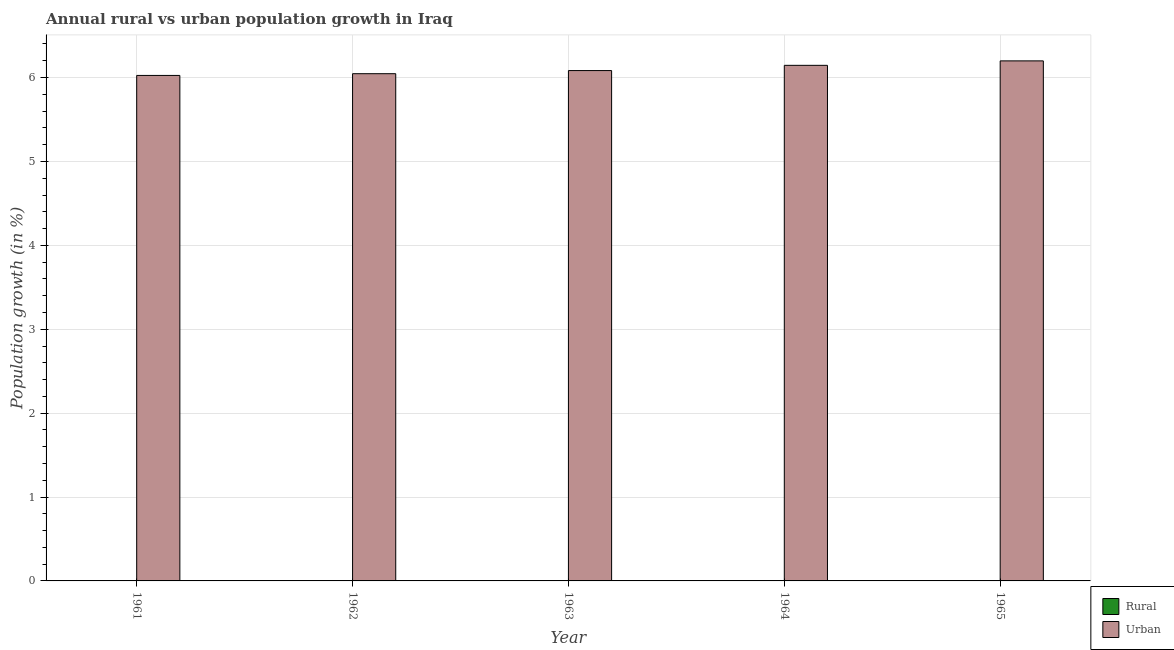Are the number of bars per tick equal to the number of legend labels?
Provide a succinct answer. No. What is the label of the 1st group of bars from the left?
Offer a terse response. 1961. In how many cases, is the number of bars for a given year not equal to the number of legend labels?
Ensure brevity in your answer.  5. Across all years, what is the maximum urban population growth?
Offer a terse response. 6.2. In which year was the urban population growth maximum?
Make the answer very short. 1965. What is the total rural population growth in the graph?
Provide a short and direct response. 0. What is the difference between the urban population growth in 1963 and that in 1964?
Give a very brief answer. -0.06. What is the difference between the urban population growth in 1961 and the rural population growth in 1964?
Your response must be concise. -0.12. What is the average rural population growth per year?
Keep it short and to the point. 0. In how many years, is the urban population growth greater than 2.6 %?
Give a very brief answer. 5. What is the ratio of the urban population growth in 1961 to that in 1963?
Your response must be concise. 0.99. Is the difference between the urban population growth in 1961 and 1965 greater than the difference between the rural population growth in 1961 and 1965?
Your response must be concise. No. What is the difference between the highest and the second highest urban population growth?
Keep it short and to the point. 0.05. What is the difference between the highest and the lowest urban population growth?
Keep it short and to the point. 0.17. In how many years, is the urban population growth greater than the average urban population growth taken over all years?
Offer a terse response. 2. Are all the bars in the graph horizontal?
Your answer should be very brief. No. Does the graph contain any zero values?
Your answer should be very brief. Yes. Does the graph contain grids?
Give a very brief answer. Yes. How many legend labels are there?
Your answer should be compact. 2. How are the legend labels stacked?
Offer a very short reply. Vertical. What is the title of the graph?
Provide a short and direct response. Annual rural vs urban population growth in Iraq. What is the label or title of the X-axis?
Ensure brevity in your answer.  Year. What is the label or title of the Y-axis?
Your answer should be compact. Population growth (in %). What is the Population growth (in %) in Urban  in 1961?
Your answer should be very brief. 6.03. What is the Population growth (in %) of Urban  in 1962?
Your response must be concise. 6.05. What is the Population growth (in %) of Urban  in 1963?
Your answer should be very brief. 6.08. What is the Population growth (in %) in Urban  in 1964?
Your answer should be compact. 6.15. What is the Population growth (in %) of Urban  in 1965?
Provide a short and direct response. 6.2. Across all years, what is the maximum Population growth (in %) of Urban ?
Your answer should be compact. 6.2. Across all years, what is the minimum Population growth (in %) of Urban ?
Provide a succinct answer. 6.03. What is the total Population growth (in %) in Rural in the graph?
Make the answer very short. 0. What is the total Population growth (in %) of Urban  in the graph?
Your response must be concise. 30.5. What is the difference between the Population growth (in %) of Urban  in 1961 and that in 1962?
Your answer should be compact. -0.02. What is the difference between the Population growth (in %) in Urban  in 1961 and that in 1963?
Offer a terse response. -0.06. What is the difference between the Population growth (in %) of Urban  in 1961 and that in 1964?
Ensure brevity in your answer.  -0.12. What is the difference between the Population growth (in %) of Urban  in 1961 and that in 1965?
Make the answer very short. -0.17. What is the difference between the Population growth (in %) in Urban  in 1962 and that in 1963?
Ensure brevity in your answer.  -0.04. What is the difference between the Population growth (in %) of Urban  in 1962 and that in 1964?
Your response must be concise. -0.1. What is the difference between the Population growth (in %) in Urban  in 1962 and that in 1965?
Keep it short and to the point. -0.15. What is the difference between the Population growth (in %) in Urban  in 1963 and that in 1964?
Your answer should be very brief. -0.06. What is the difference between the Population growth (in %) of Urban  in 1963 and that in 1965?
Ensure brevity in your answer.  -0.12. What is the difference between the Population growth (in %) of Urban  in 1964 and that in 1965?
Your response must be concise. -0.05. What is the average Population growth (in %) in Urban  per year?
Your answer should be very brief. 6.1. What is the ratio of the Population growth (in %) in Urban  in 1961 to that in 1964?
Make the answer very short. 0.98. What is the ratio of the Population growth (in %) of Urban  in 1962 to that in 1964?
Make the answer very short. 0.98. What is the ratio of the Population growth (in %) in Urban  in 1962 to that in 1965?
Your response must be concise. 0.98. What is the ratio of the Population growth (in %) of Urban  in 1963 to that in 1965?
Keep it short and to the point. 0.98. What is the difference between the highest and the second highest Population growth (in %) of Urban ?
Your answer should be compact. 0.05. What is the difference between the highest and the lowest Population growth (in %) of Urban ?
Ensure brevity in your answer.  0.17. 